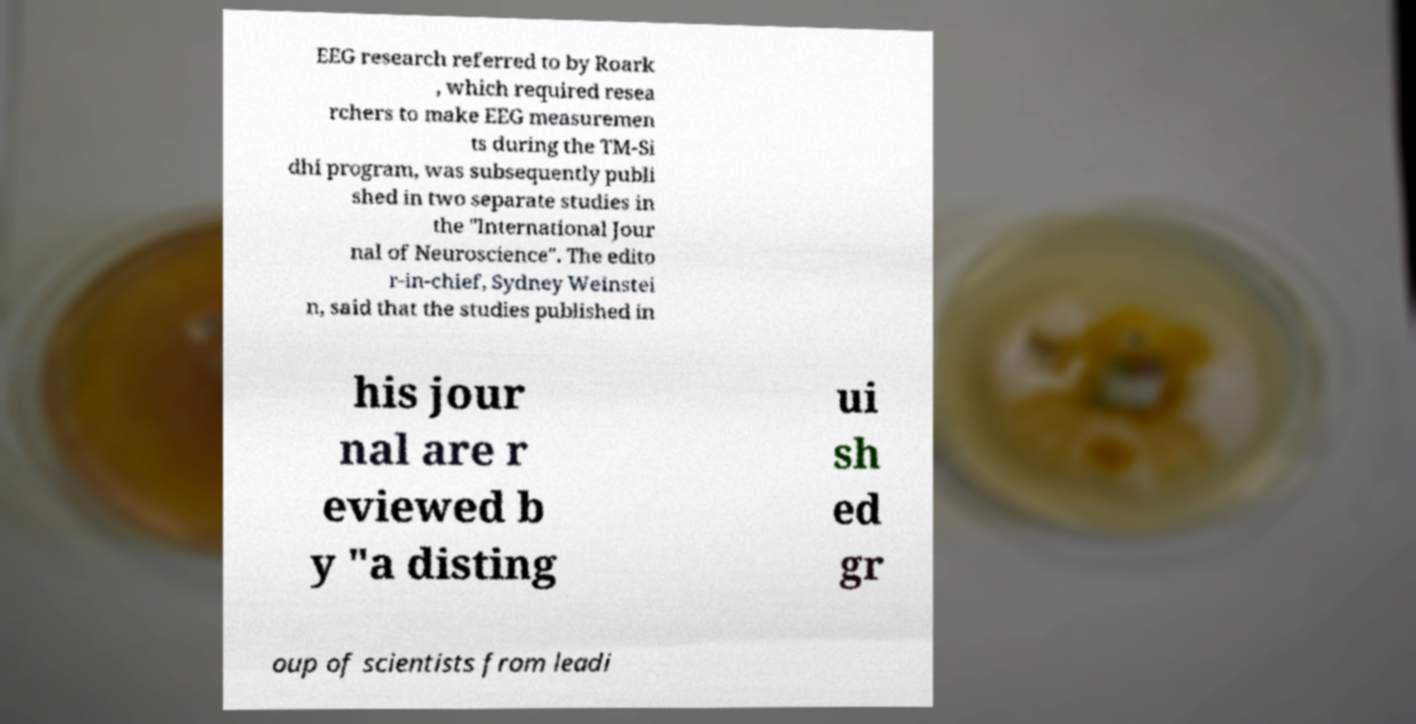Please identify and transcribe the text found in this image. EEG research referred to by Roark , which required resea rchers to make EEG measuremen ts during the TM-Si dhi program, was subsequently publi shed in two separate studies in the "International Jour nal of Neuroscience". The edito r-in-chief, Sydney Weinstei n, said that the studies published in his jour nal are r eviewed b y "a disting ui sh ed gr oup of scientists from leadi 